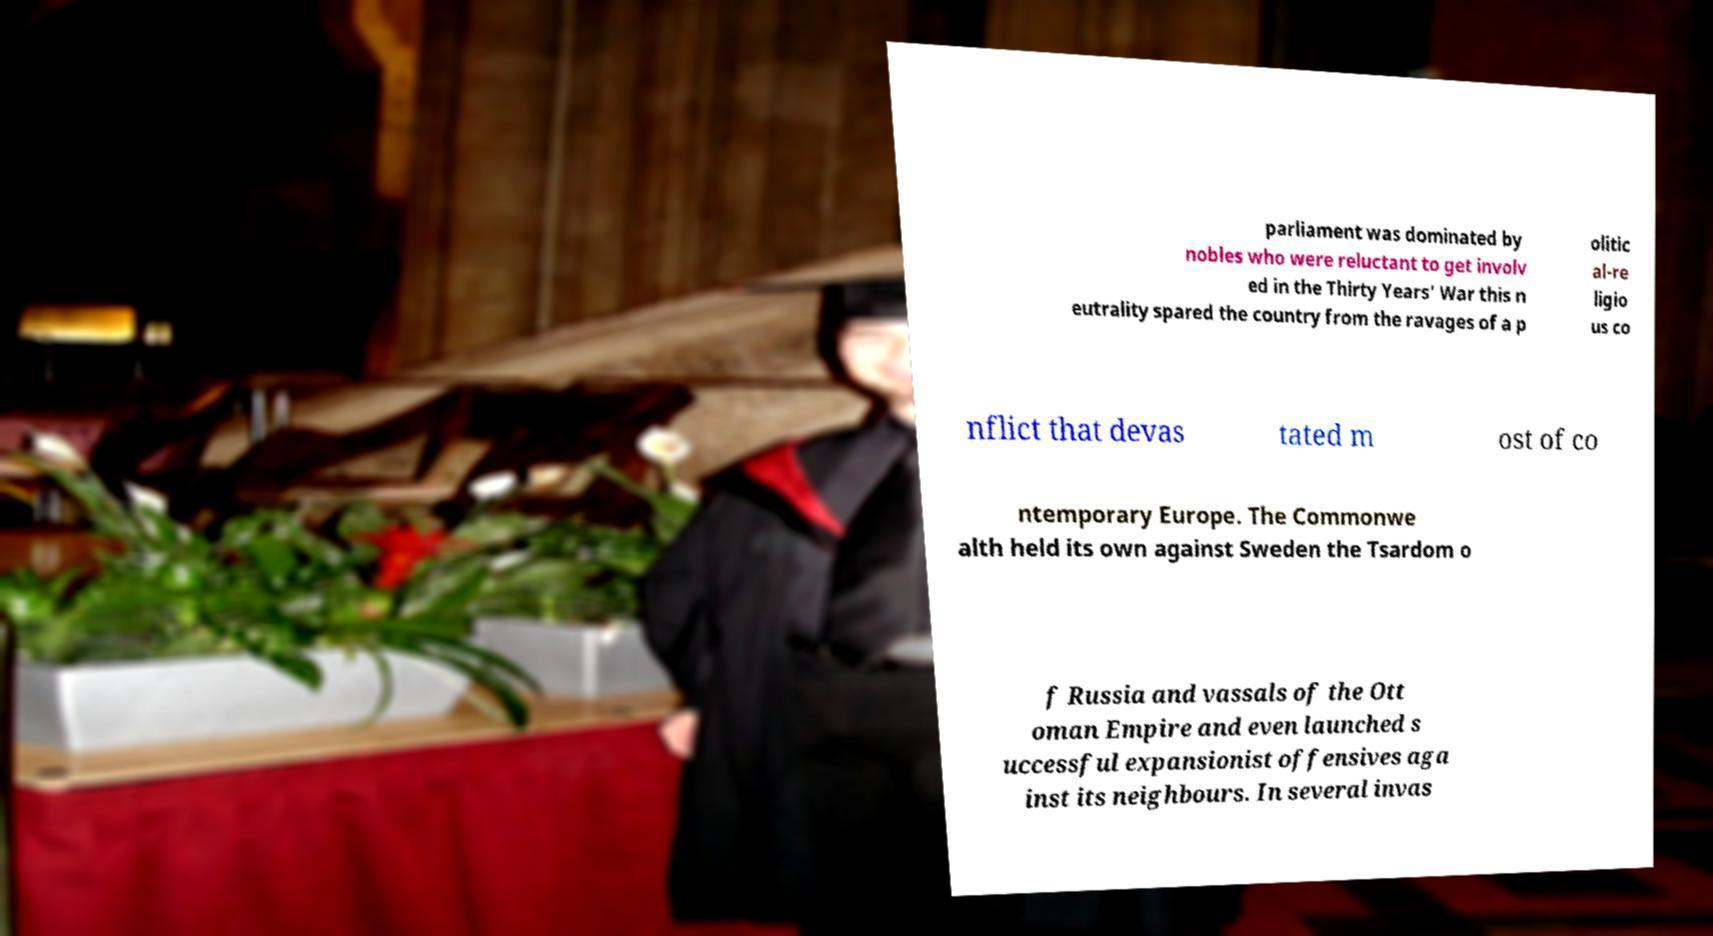Please identify and transcribe the text found in this image. parliament was dominated by nobles who were reluctant to get involv ed in the Thirty Years' War this n eutrality spared the country from the ravages of a p olitic al-re ligio us co nflict that devas tated m ost of co ntemporary Europe. The Commonwe alth held its own against Sweden the Tsardom o f Russia and vassals of the Ott oman Empire and even launched s uccessful expansionist offensives aga inst its neighbours. In several invas 